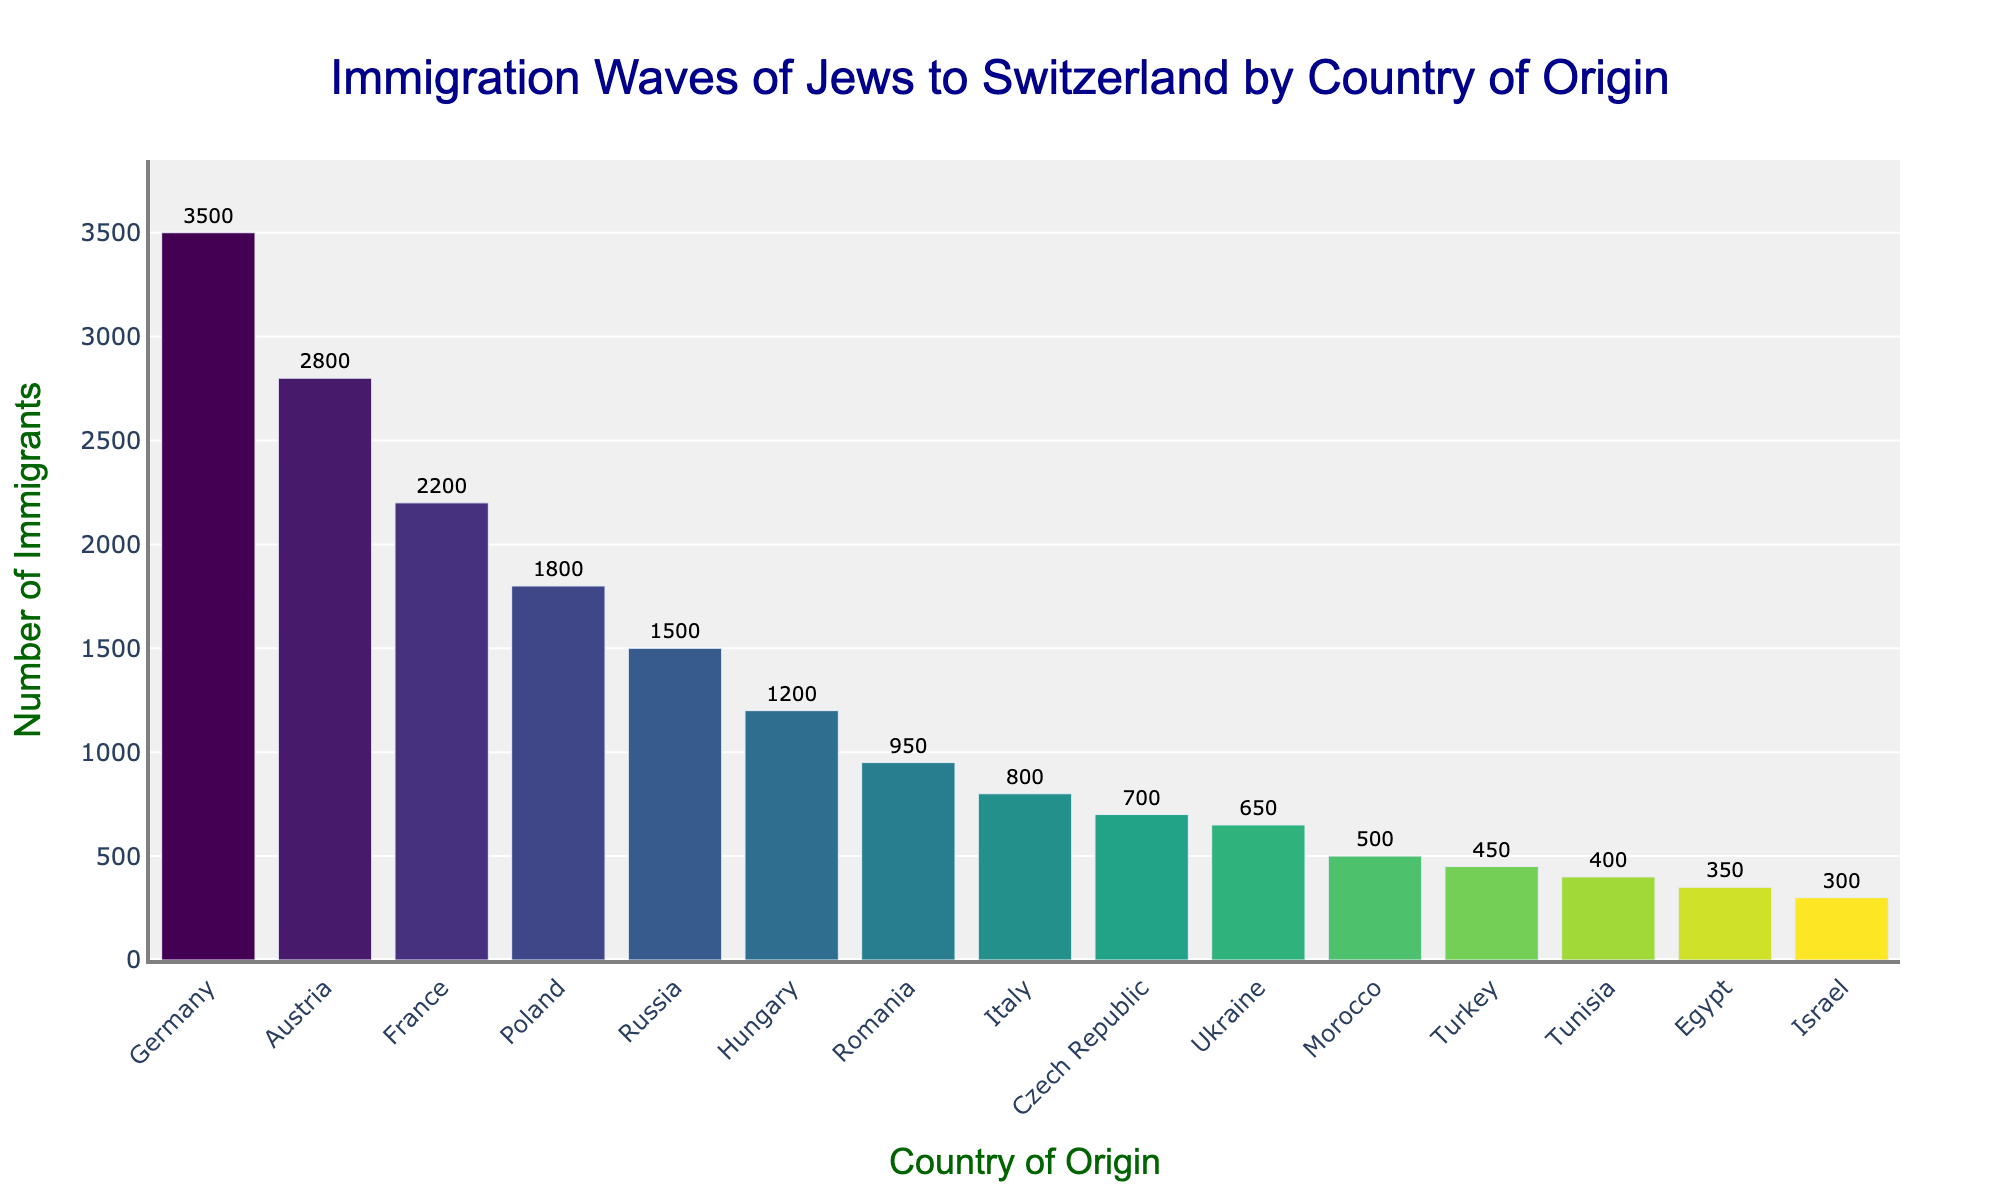How many Jews immigrated from Germany and Austria combined? To find the total number of immigrants from Germany and Austria, sum the numbers from both countries: 3500 (Germany) + 2800 (Austria).
Answer: 6300 Which country has the lowest number of Jewish immigrants to Switzerland? Identify the country with the smallest bar in the chart. Egypt has the bar with the smallest height, indicating the least number of immigrants.
Answer: Israel Are there more immigrants from Poland or Hungary? Compare the heights of the bars for Poland and Hungary. The bar for Poland is taller than the bar for Hungary, indicating more immigrants.
Answer: Poland Which countries have more than 2000 Jewish immigrants each? Examine the heights of the bars and check their corresponding values. Germany, Austria, and France have bars that exceed 2000.
Answer: Germany, Austria, France What is the average number of immigrants from Turkey, Tunisia, and Egypt? Add the number of immigrants for Turkey (450), Tunisia (400), and Egypt (350), then divide by the number of countries: (450 + 400 + 350) / 3.
Answer: 400 How many more immigrants came from France compared to Russia? Subtract the number of immigrants from Russia from the number of immigrants from France: 2200 (France) - 1500 (Russia).
Answer: 700 Are there more immigrants from Israel than from Egypt? Compare the heights of the bars for Israel and Egypt. The bar for Israel is shorter, indicating fewer immigrants than Egypt.
Answer: No Which country between Ukraine and Romania had fewer Jewish immigrants to Switzerland? Compare the heights and values of the bars for Ukraine and Romania. Ukraine has a smaller bar, indicating fewer immigrants.
Answer: Ukraine Do any countries have the same number of immigrants, and if so, which? None of the bars in the bar chart have the same height, indicating that no two countries have the identical number of Jewish immigrants.
Answer: No What is the total number of Jewish immigrants from the top five countries? Sum the number of immigrants from the top five countries: Germany (3500), Austria (2800), France (2200), Poland (1800), and Russia (1500): 3500 + 2800 + 2200 + 1800 + 1500.
Answer: 11800 